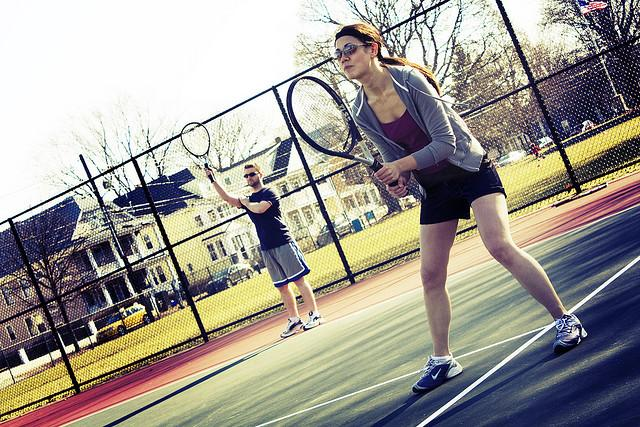What configuration of tennis is being played here?

Choices:
A) racial
B) swoop hawk
C) singles
D) doubles doubles 